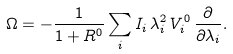Convert formula to latex. <formula><loc_0><loc_0><loc_500><loc_500>\Omega = - \frac { 1 } { 1 + R ^ { 0 } } \sum _ { i } I _ { i } \, \lambda _ { i } ^ { 2 } \, V _ { i } ^ { 0 } \, \frac { \partial } { \partial \lambda _ { i } } .</formula> 